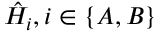Convert formula to latex. <formula><loc_0><loc_0><loc_500><loc_500>\hat { H } _ { i } , i \in \{ A , B \}</formula> 